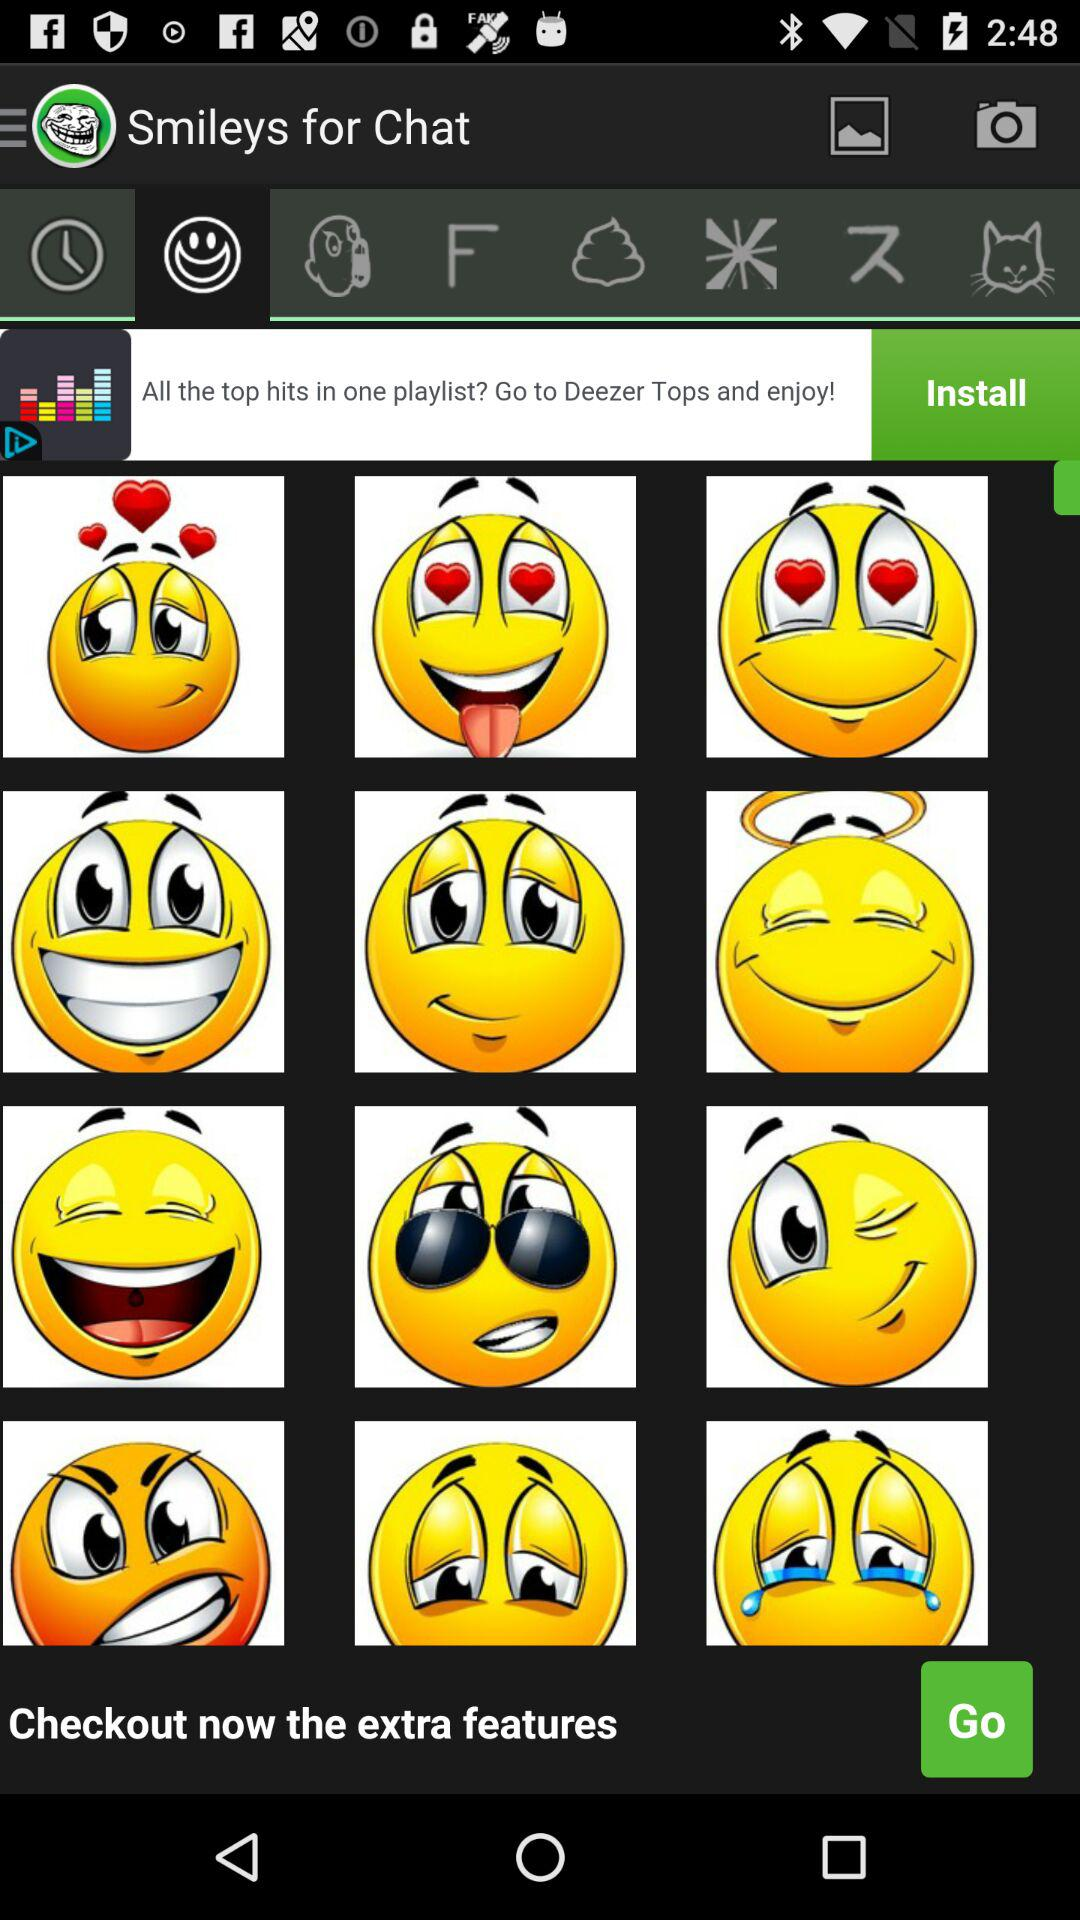How many smiley faces have hearts in their eyes?
Answer the question using a single word or phrase. 2 